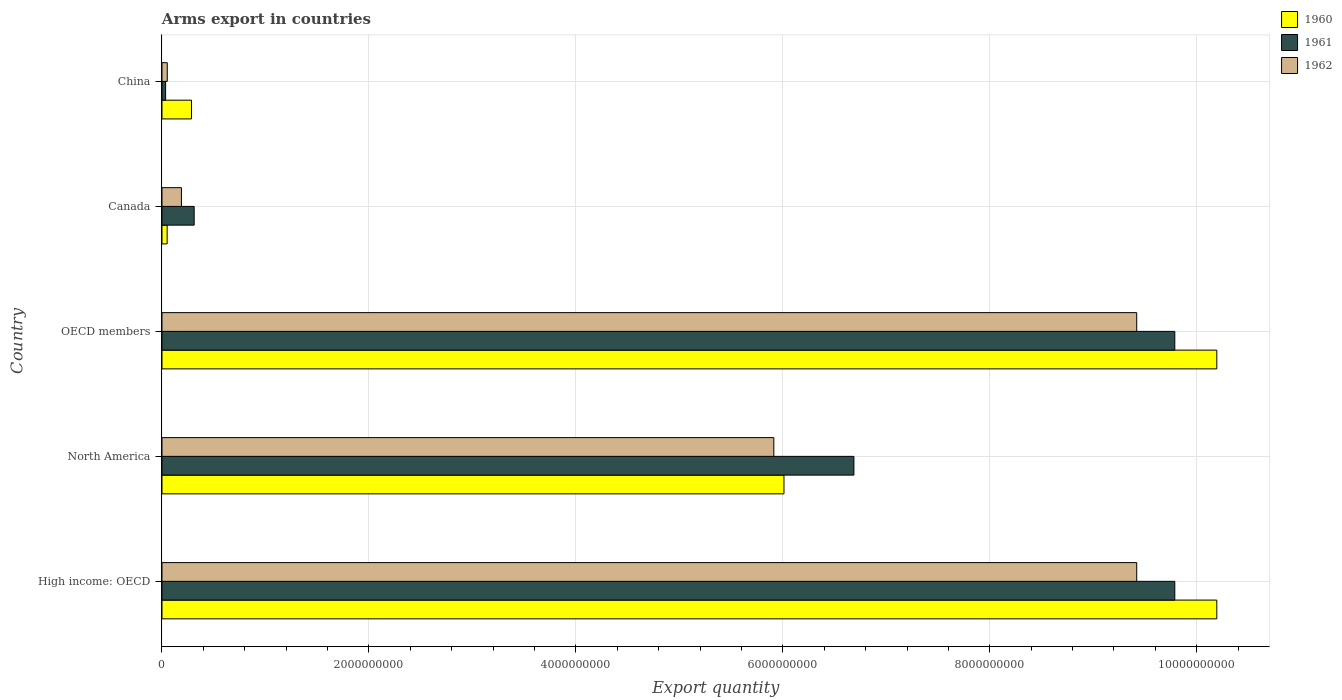How many different coloured bars are there?
Ensure brevity in your answer.  3. Are the number of bars per tick equal to the number of legend labels?
Offer a terse response. Yes. How many bars are there on the 1st tick from the top?
Offer a terse response. 3. What is the total arms export in 1960 in North America?
Keep it short and to the point. 6.01e+09. Across all countries, what is the maximum total arms export in 1960?
Make the answer very short. 1.02e+1. Across all countries, what is the minimum total arms export in 1961?
Provide a short and direct response. 3.50e+07. In which country was the total arms export in 1962 maximum?
Provide a short and direct response. High income: OECD. In which country was the total arms export in 1960 minimum?
Your answer should be very brief. Canada. What is the total total arms export in 1962 in the graph?
Provide a succinct answer. 2.50e+1. What is the difference between the total arms export in 1960 in Canada and that in China?
Your answer should be compact. -2.35e+08. What is the difference between the total arms export in 1962 in High income: OECD and the total arms export in 1961 in Canada?
Ensure brevity in your answer.  9.11e+09. What is the average total arms export in 1961 per country?
Provide a succinct answer. 5.32e+09. What is the difference between the total arms export in 1961 and total arms export in 1960 in High income: OECD?
Your answer should be very brief. -4.06e+08. In how many countries, is the total arms export in 1960 greater than 2400000000 ?
Offer a very short reply. 3. What is the ratio of the total arms export in 1960 in Canada to that in OECD members?
Give a very brief answer. 0. What is the difference between the highest and the second highest total arms export in 1961?
Your answer should be very brief. 0. What is the difference between the highest and the lowest total arms export in 1961?
Keep it short and to the point. 9.75e+09. In how many countries, is the total arms export in 1962 greater than the average total arms export in 1962 taken over all countries?
Offer a very short reply. 3. Is the sum of the total arms export in 1962 in China and North America greater than the maximum total arms export in 1960 across all countries?
Offer a terse response. No. What does the 2nd bar from the top in North America represents?
Ensure brevity in your answer.  1961. Is it the case that in every country, the sum of the total arms export in 1961 and total arms export in 1962 is greater than the total arms export in 1960?
Your response must be concise. No. How many bars are there?
Your response must be concise. 15. Does the graph contain any zero values?
Ensure brevity in your answer.  No. Where does the legend appear in the graph?
Give a very brief answer. Top right. How many legend labels are there?
Keep it short and to the point. 3. What is the title of the graph?
Provide a succinct answer. Arms export in countries. Does "1968" appear as one of the legend labels in the graph?
Provide a succinct answer. No. What is the label or title of the X-axis?
Offer a terse response. Export quantity. What is the Export quantity of 1960 in High income: OECD?
Provide a short and direct response. 1.02e+1. What is the Export quantity in 1961 in High income: OECD?
Offer a very short reply. 9.79e+09. What is the Export quantity in 1962 in High income: OECD?
Offer a very short reply. 9.42e+09. What is the Export quantity of 1960 in North America?
Give a very brief answer. 6.01e+09. What is the Export quantity of 1961 in North America?
Make the answer very short. 6.69e+09. What is the Export quantity in 1962 in North America?
Make the answer very short. 5.91e+09. What is the Export quantity in 1960 in OECD members?
Ensure brevity in your answer.  1.02e+1. What is the Export quantity of 1961 in OECD members?
Your answer should be compact. 9.79e+09. What is the Export quantity in 1962 in OECD members?
Your answer should be compact. 9.42e+09. What is the Export quantity in 1961 in Canada?
Ensure brevity in your answer.  3.11e+08. What is the Export quantity in 1962 in Canada?
Your response must be concise. 1.88e+08. What is the Export quantity of 1960 in China?
Make the answer very short. 2.85e+08. What is the Export quantity of 1961 in China?
Keep it short and to the point. 3.50e+07. What is the Export quantity of 1962 in China?
Make the answer very short. 5.10e+07. Across all countries, what is the maximum Export quantity in 1960?
Make the answer very short. 1.02e+1. Across all countries, what is the maximum Export quantity of 1961?
Your answer should be compact. 9.79e+09. Across all countries, what is the maximum Export quantity of 1962?
Provide a succinct answer. 9.42e+09. Across all countries, what is the minimum Export quantity of 1960?
Your response must be concise. 5.00e+07. Across all countries, what is the minimum Export quantity of 1961?
Your answer should be compact. 3.50e+07. Across all countries, what is the minimum Export quantity in 1962?
Ensure brevity in your answer.  5.10e+07. What is the total Export quantity in 1960 in the graph?
Give a very brief answer. 2.67e+1. What is the total Export quantity of 1961 in the graph?
Your answer should be very brief. 2.66e+1. What is the total Export quantity in 1962 in the graph?
Your answer should be compact. 2.50e+1. What is the difference between the Export quantity in 1960 in High income: OECD and that in North America?
Make the answer very short. 4.18e+09. What is the difference between the Export quantity in 1961 in High income: OECD and that in North America?
Make the answer very short. 3.10e+09. What is the difference between the Export quantity in 1962 in High income: OECD and that in North America?
Your response must be concise. 3.51e+09. What is the difference between the Export quantity of 1961 in High income: OECD and that in OECD members?
Offer a very short reply. 0. What is the difference between the Export quantity in 1960 in High income: OECD and that in Canada?
Your response must be concise. 1.01e+1. What is the difference between the Export quantity of 1961 in High income: OECD and that in Canada?
Offer a terse response. 9.48e+09. What is the difference between the Export quantity in 1962 in High income: OECD and that in Canada?
Your answer should be very brief. 9.23e+09. What is the difference between the Export quantity in 1960 in High income: OECD and that in China?
Ensure brevity in your answer.  9.91e+09. What is the difference between the Export quantity in 1961 in High income: OECD and that in China?
Offer a terse response. 9.75e+09. What is the difference between the Export quantity in 1962 in High income: OECD and that in China?
Ensure brevity in your answer.  9.37e+09. What is the difference between the Export quantity of 1960 in North America and that in OECD members?
Provide a succinct answer. -4.18e+09. What is the difference between the Export quantity of 1961 in North America and that in OECD members?
Offer a very short reply. -3.10e+09. What is the difference between the Export quantity in 1962 in North America and that in OECD members?
Offer a terse response. -3.51e+09. What is the difference between the Export quantity in 1960 in North America and that in Canada?
Your response must be concise. 5.96e+09. What is the difference between the Export quantity in 1961 in North America and that in Canada?
Your answer should be compact. 6.38e+09. What is the difference between the Export quantity in 1962 in North America and that in Canada?
Provide a succinct answer. 5.72e+09. What is the difference between the Export quantity of 1960 in North America and that in China?
Your answer should be compact. 5.73e+09. What is the difference between the Export quantity of 1961 in North America and that in China?
Make the answer very short. 6.65e+09. What is the difference between the Export quantity of 1962 in North America and that in China?
Your answer should be compact. 5.86e+09. What is the difference between the Export quantity in 1960 in OECD members and that in Canada?
Provide a succinct answer. 1.01e+1. What is the difference between the Export quantity in 1961 in OECD members and that in Canada?
Offer a very short reply. 9.48e+09. What is the difference between the Export quantity of 1962 in OECD members and that in Canada?
Provide a short and direct response. 9.23e+09. What is the difference between the Export quantity of 1960 in OECD members and that in China?
Ensure brevity in your answer.  9.91e+09. What is the difference between the Export quantity in 1961 in OECD members and that in China?
Provide a succinct answer. 9.75e+09. What is the difference between the Export quantity of 1962 in OECD members and that in China?
Make the answer very short. 9.37e+09. What is the difference between the Export quantity in 1960 in Canada and that in China?
Ensure brevity in your answer.  -2.35e+08. What is the difference between the Export quantity in 1961 in Canada and that in China?
Offer a terse response. 2.76e+08. What is the difference between the Export quantity of 1962 in Canada and that in China?
Provide a short and direct response. 1.37e+08. What is the difference between the Export quantity of 1960 in High income: OECD and the Export quantity of 1961 in North America?
Give a very brief answer. 3.51e+09. What is the difference between the Export quantity of 1960 in High income: OECD and the Export quantity of 1962 in North America?
Your answer should be compact. 4.28e+09. What is the difference between the Export quantity of 1961 in High income: OECD and the Export quantity of 1962 in North America?
Provide a short and direct response. 3.88e+09. What is the difference between the Export quantity of 1960 in High income: OECD and the Export quantity of 1961 in OECD members?
Make the answer very short. 4.06e+08. What is the difference between the Export quantity in 1960 in High income: OECD and the Export quantity in 1962 in OECD members?
Ensure brevity in your answer.  7.74e+08. What is the difference between the Export quantity of 1961 in High income: OECD and the Export quantity of 1962 in OECD members?
Give a very brief answer. 3.68e+08. What is the difference between the Export quantity of 1960 in High income: OECD and the Export quantity of 1961 in Canada?
Provide a succinct answer. 9.88e+09. What is the difference between the Export quantity of 1960 in High income: OECD and the Export quantity of 1962 in Canada?
Your response must be concise. 1.00e+1. What is the difference between the Export quantity of 1961 in High income: OECD and the Export quantity of 1962 in Canada?
Make the answer very short. 9.60e+09. What is the difference between the Export quantity in 1960 in High income: OECD and the Export quantity in 1961 in China?
Make the answer very short. 1.02e+1. What is the difference between the Export quantity in 1960 in High income: OECD and the Export quantity in 1962 in China?
Your response must be concise. 1.01e+1. What is the difference between the Export quantity of 1961 in High income: OECD and the Export quantity of 1962 in China?
Make the answer very short. 9.74e+09. What is the difference between the Export quantity in 1960 in North America and the Export quantity in 1961 in OECD members?
Your response must be concise. -3.78e+09. What is the difference between the Export quantity of 1960 in North America and the Export quantity of 1962 in OECD members?
Make the answer very short. -3.41e+09. What is the difference between the Export quantity in 1961 in North America and the Export quantity in 1962 in OECD members?
Offer a very short reply. -2.73e+09. What is the difference between the Export quantity of 1960 in North America and the Export quantity of 1961 in Canada?
Offer a very short reply. 5.70e+09. What is the difference between the Export quantity in 1960 in North America and the Export quantity in 1962 in Canada?
Your response must be concise. 5.82e+09. What is the difference between the Export quantity of 1961 in North America and the Export quantity of 1962 in Canada?
Your response must be concise. 6.50e+09. What is the difference between the Export quantity of 1960 in North America and the Export quantity of 1961 in China?
Offer a very short reply. 5.98e+09. What is the difference between the Export quantity in 1960 in North America and the Export quantity in 1962 in China?
Give a very brief answer. 5.96e+09. What is the difference between the Export quantity of 1961 in North America and the Export quantity of 1962 in China?
Offer a very short reply. 6.64e+09. What is the difference between the Export quantity in 1960 in OECD members and the Export quantity in 1961 in Canada?
Your answer should be very brief. 9.88e+09. What is the difference between the Export quantity of 1960 in OECD members and the Export quantity of 1962 in Canada?
Your answer should be compact. 1.00e+1. What is the difference between the Export quantity in 1961 in OECD members and the Export quantity in 1962 in Canada?
Make the answer very short. 9.60e+09. What is the difference between the Export quantity in 1960 in OECD members and the Export quantity in 1961 in China?
Your response must be concise. 1.02e+1. What is the difference between the Export quantity in 1960 in OECD members and the Export quantity in 1962 in China?
Provide a succinct answer. 1.01e+1. What is the difference between the Export quantity of 1961 in OECD members and the Export quantity of 1962 in China?
Offer a very short reply. 9.74e+09. What is the difference between the Export quantity in 1960 in Canada and the Export quantity in 1961 in China?
Keep it short and to the point. 1.50e+07. What is the difference between the Export quantity of 1960 in Canada and the Export quantity of 1962 in China?
Provide a short and direct response. -1.00e+06. What is the difference between the Export quantity in 1961 in Canada and the Export quantity in 1962 in China?
Your answer should be very brief. 2.60e+08. What is the average Export quantity in 1960 per country?
Your answer should be very brief. 5.35e+09. What is the average Export quantity of 1961 per country?
Ensure brevity in your answer.  5.32e+09. What is the average Export quantity in 1962 per country?
Your answer should be very brief. 5.00e+09. What is the difference between the Export quantity in 1960 and Export quantity in 1961 in High income: OECD?
Your response must be concise. 4.06e+08. What is the difference between the Export quantity in 1960 and Export quantity in 1962 in High income: OECD?
Your answer should be very brief. 7.74e+08. What is the difference between the Export quantity in 1961 and Export quantity in 1962 in High income: OECD?
Provide a succinct answer. 3.68e+08. What is the difference between the Export quantity of 1960 and Export quantity of 1961 in North America?
Give a very brief answer. -6.76e+08. What is the difference between the Export quantity of 1960 and Export quantity of 1962 in North America?
Offer a very short reply. 9.80e+07. What is the difference between the Export quantity of 1961 and Export quantity of 1962 in North America?
Offer a very short reply. 7.74e+08. What is the difference between the Export quantity in 1960 and Export quantity in 1961 in OECD members?
Make the answer very short. 4.06e+08. What is the difference between the Export quantity of 1960 and Export quantity of 1962 in OECD members?
Ensure brevity in your answer.  7.74e+08. What is the difference between the Export quantity of 1961 and Export quantity of 1962 in OECD members?
Ensure brevity in your answer.  3.68e+08. What is the difference between the Export quantity in 1960 and Export quantity in 1961 in Canada?
Keep it short and to the point. -2.61e+08. What is the difference between the Export quantity of 1960 and Export quantity of 1962 in Canada?
Ensure brevity in your answer.  -1.38e+08. What is the difference between the Export quantity in 1961 and Export quantity in 1962 in Canada?
Your answer should be compact. 1.23e+08. What is the difference between the Export quantity of 1960 and Export quantity of 1961 in China?
Your response must be concise. 2.50e+08. What is the difference between the Export quantity in 1960 and Export quantity in 1962 in China?
Provide a short and direct response. 2.34e+08. What is the difference between the Export quantity of 1961 and Export quantity of 1962 in China?
Give a very brief answer. -1.60e+07. What is the ratio of the Export quantity in 1960 in High income: OECD to that in North America?
Keep it short and to the point. 1.7. What is the ratio of the Export quantity of 1961 in High income: OECD to that in North America?
Your answer should be very brief. 1.46. What is the ratio of the Export quantity in 1962 in High income: OECD to that in North America?
Provide a succinct answer. 1.59. What is the ratio of the Export quantity of 1960 in High income: OECD to that in OECD members?
Provide a succinct answer. 1. What is the ratio of the Export quantity of 1961 in High income: OECD to that in OECD members?
Offer a terse response. 1. What is the ratio of the Export quantity of 1960 in High income: OECD to that in Canada?
Ensure brevity in your answer.  203.88. What is the ratio of the Export quantity of 1961 in High income: OECD to that in Canada?
Make the answer very short. 31.47. What is the ratio of the Export quantity of 1962 in High income: OECD to that in Canada?
Provide a short and direct response. 50.11. What is the ratio of the Export quantity in 1960 in High income: OECD to that in China?
Your answer should be very brief. 35.77. What is the ratio of the Export quantity in 1961 in High income: OECD to that in China?
Your answer should be very brief. 279.66. What is the ratio of the Export quantity in 1962 in High income: OECD to that in China?
Provide a succinct answer. 184.71. What is the ratio of the Export quantity in 1960 in North America to that in OECD members?
Give a very brief answer. 0.59. What is the ratio of the Export quantity in 1961 in North America to that in OECD members?
Keep it short and to the point. 0.68. What is the ratio of the Export quantity in 1962 in North America to that in OECD members?
Your response must be concise. 0.63. What is the ratio of the Export quantity in 1960 in North America to that in Canada?
Your answer should be very brief. 120.22. What is the ratio of the Export quantity in 1961 in North America to that in Canada?
Provide a short and direct response. 21.5. What is the ratio of the Export quantity of 1962 in North America to that in Canada?
Ensure brevity in your answer.  31.45. What is the ratio of the Export quantity of 1960 in North America to that in China?
Your answer should be very brief. 21.09. What is the ratio of the Export quantity in 1961 in North America to that in China?
Your response must be concise. 191.06. What is the ratio of the Export quantity of 1962 in North America to that in China?
Keep it short and to the point. 115.94. What is the ratio of the Export quantity of 1960 in OECD members to that in Canada?
Offer a very short reply. 203.88. What is the ratio of the Export quantity in 1961 in OECD members to that in Canada?
Give a very brief answer. 31.47. What is the ratio of the Export quantity of 1962 in OECD members to that in Canada?
Offer a very short reply. 50.11. What is the ratio of the Export quantity of 1960 in OECD members to that in China?
Provide a succinct answer. 35.77. What is the ratio of the Export quantity of 1961 in OECD members to that in China?
Your response must be concise. 279.66. What is the ratio of the Export quantity in 1962 in OECD members to that in China?
Make the answer very short. 184.71. What is the ratio of the Export quantity of 1960 in Canada to that in China?
Make the answer very short. 0.18. What is the ratio of the Export quantity in 1961 in Canada to that in China?
Your answer should be very brief. 8.89. What is the ratio of the Export quantity in 1962 in Canada to that in China?
Ensure brevity in your answer.  3.69. What is the difference between the highest and the second highest Export quantity in 1961?
Keep it short and to the point. 0. What is the difference between the highest and the second highest Export quantity of 1962?
Offer a very short reply. 0. What is the difference between the highest and the lowest Export quantity of 1960?
Make the answer very short. 1.01e+1. What is the difference between the highest and the lowest Export quantity in 1961?
Your answer should be very brief. 9.75e+09. What is the difference between the highest and the lowest Export quantity in 1962?
Keep it short and to the point. 9.37e+09. 